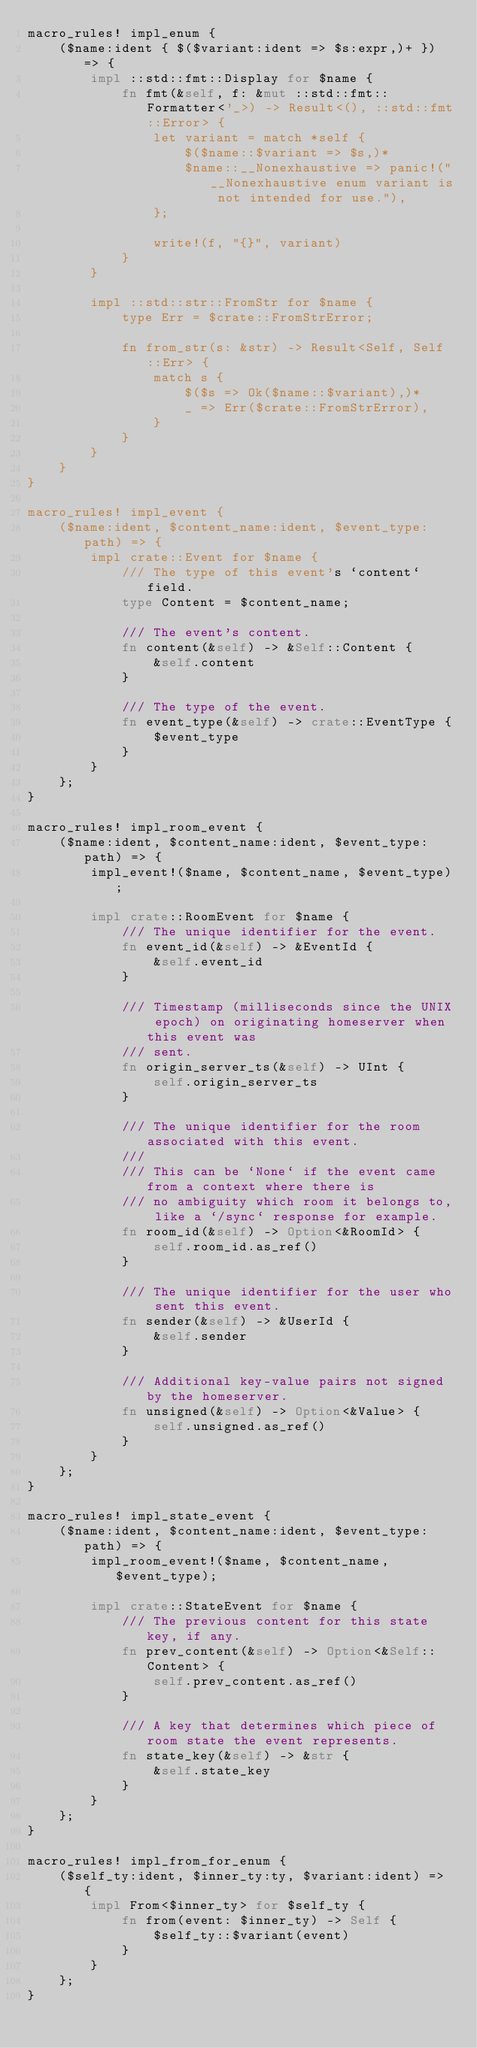Convert code to text. <code><loc_0><loc_0><loc_500><loc_500><_Rust_>macro_rules! impl_enum {
    ($name:ident { $($variant:ident => $s:expr,)+ }) => {
        impl ::std::fmt::Display for $name {
            fn fmt(&self, f: &mut ::std::fmt::Formatter<'_>) -> Result<(), ::std::fmt::Error> {
                let variant = match *self {
                    $($name::$variant => $s,)*
                    $name::__Nonexhaustive => panic!("__Nonexhaustive enum variant is not intended for use."),
                };

                write!(f, "{}", variant)
            }
        }

        impl ::std::str::FromStr for $name {
            type Err = $crate::FromStrError;

            fn from_str(s: &str) -> Result<Self, Self::Err> {
                match s {
                    $($s => Ok($name::$variant),)*
                    _ => Err($crate::FromStrError),
                }
            }
        }
    }
}

macro_rules! impl_event {
    ($name:ident, $content_name:ident, $event_type:path) => {
        impl crate::Event for $name {
            /// The type of this event's `content` field.
            type Content = $content_name;

            /// The event's content.
            fn content(&self) -> &Self::Content {
                &self.content
            }

            /// The type of the event.
            fn event_type(&self) -> crate::EventType {
                $event_type
            }
        }
    };
}

macro_rules! impl_room_event {
    ($name:ident, $content_name:ident, $event_type:path) => {
        impl_event!($name, $content_name, $event_type);

        impl crate::RoomEvent for $name {
            /// The unique identifier for the event.
            fn event_id(&self) -> &EventId {
                &self.event_id
            }

            /// Timestamp (milliseconds since the UNIX epoch) on originating homeserver when this event was
            /// sent.
            fn origin_server_ts(&self) -> UInt {
                self.origin_server_ts
            }

            /// The unique identifier for the room associated with this event.
            ///
            /// This can be `None` if the event came from a context where there is
            /// no ambiguity which room it belongs to, like a `/sync` response for example.
            fn room_id(&self) -> Option<&RoomId> {
                self.room_id.as_ref()
            }

            /// The unique identifier for the user who sent this event.
            fn sender(&self) -> &UserId {
                &self.sender
            }

            /// Additional key-value pairs not signed by the homeserver.
            fn unsigned(&self) -> Option<&Value> {
                self.unsigned.as_ref()
            }
        }
    };
}

macro_rules! impl_state_event {
    ($name:ident, $content_name:ident, $event_type:path) => {
        impl_room_event!($name, $content_name, $event_type);

        impl crate::StateEvent for $name {
            /// The previous content for this state key, if any.
            fn prev_content(&self) -> Option<&Self::Content> {
                self.prev_content.as_ref()
            }

            /// A key that determines which piece of room state the event represents.
            fn state_key(&self) -> &str {
                &self.state_key
            }
        }
    };
}

macro_rules! impl_from_for_enum {
    ($self_ty:ident, $inner_ty:ty, $variant:ident) => {
        impl From<$inner_ty> for $self_ty {
            fn from(event: $inner_ty) -> Self {
                $self_ty::$variant(event)
            }
        }
    };
}
</code> 